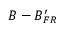Convert formula to latex. <formula><loc_0><loc_0><loc_500><loc_500>B - B _ { F R } ^ { \prime }</formula> 